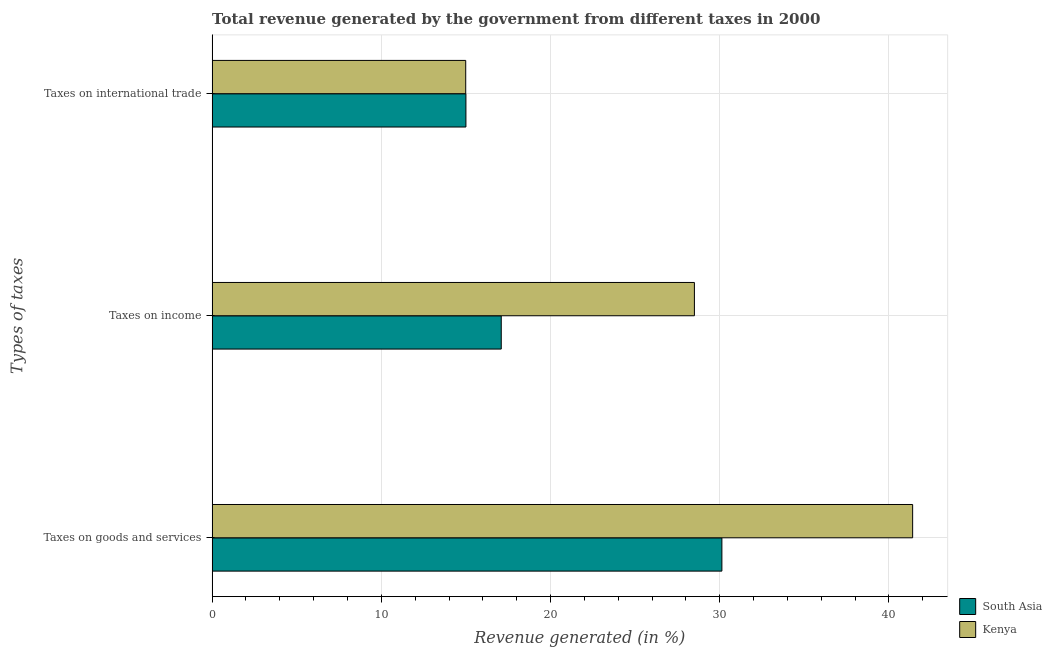How many different coloured bars are there?
Your response must be concise. 2. How many groups of bars are there?
Your answer should be very brief. 3. Are the number of bars on each tick of the Y-axis equal?
Give a very brief answer. Yes. How many bars are there on the 3rd tick from the top?
Offer a terse response. 2. How many bars are there on the 3rd tick from the bottom?
Offer a terse response. 2. What is the label of the 1st group of bars from the top?
Ensure brevity in your answer.  Taxes on international trade. What is the percentage of revenue generated by taxes on goods and services in South Asia?
Give a very brief answer. 30.13. Across all countries, what is the maximum percentage of revenue generated by taxes on goods and services?
Provide a succinct answer. 41.4. Across all countries, what is the minimum percentage of revenue generated by tax on international trade?
Offer a very short reply. 14.99. In which country was the percentage of revenue generated by taxes on income maximum?
Give a very brief answer. Kenya. In which country was the percentage of revenue generated by taxes on income minimum?
Ensure brevity in your answer.  South Asia. What is the total percentage of revenue generated by taxes on income in the graph?
Your answer should be very brief. 45.59. What is the difference between the percentage of revenue generated by taxes on goods and services in Kenya and that in South Asia?
Your answer should be compact. 11.27. What is the difference between the percentage of revenue generated by tax on international trade in South Asia and the percentage of revenue generated by taxes on goods and services in Kenya?
Your answer should be compact. -26.4. What is the average percentage of revenue generated by taxes on income per country?
Keep it short and to the point. 22.8. What is the difference between the percentage of revenue generated by tax on international trade and percentage of revenue generated by taxes on income in South Asia?
Keep it short and to the point. -2.09. In how many countries, is the percentage of revenue generated by tax on international trade greater than 4 %?
Provide a succinct answer. 2. What is the ratio of the percentage of revenue generated by taxes on income in Kenya to that in South Asia?
Provide a succinct answer. 1.67. Is the percentage of revenue generated by tax on international trade in South Asia less than that in Kenya?
Give a very brief answer. No. Is the difference between the percentage of revenue generated by taxes on income in South Asia and Kenya greater than the difference between the percentage of revenue generated by tax on international trade in South Asia and Kenya?
Make the answer very short. No. What is the difference between the highest and the second highest percentage of revenue generated by taxes on goods and services?
Provide a short and direct response. 11.27. What is the difference between the highest and the lowest percentage of revenue generated by tax on international trade?
Provide a short and direct response. 0.01. In how many countries, is the percentage of revenue generated by taxes on goods and services greater than the average percentage of revenue generated by taxes on goods and services taken over all countries?
Provide a short and direct response. 1. Is the sum of the percentage of revenue generated by taxes on goods and services in Kenya and South Asia greater than the maximum percentage of revenue generated by taxes on income across all countries?
Ensure brevity in your answer.  Yes. What does the 1st bar from the top in Taxes on goods and services represents?
Keep it short and to the point. Kenya. Is it the case that in every country, the sum of the percentage of revenue generated by taxes on goods and services and percentage of revenue generated by taxes on income is greater than the percentage of revenue generated by tax on international trade?
Your answer should be very brief. Yes. Are all the bars in the graph horizontal?
Provide a succinct answer. Yes. How many countries are there in the graph?
Keep it short and to the point. 2. What is the difference between two consecutive major ticks on the X-axis?
Offer a very short reply. 10. Are the values on the major ticks of X-axis written in scientific E-notation?
Offer a very short reply. No. Does the graph contain any zero values?
Your answer should be very brief. No. Does the graph contain grids?
Keep it short and to the point. Yes. Where does the legend appear in the graph?
Make the answer very short. Bottom right. How many legend labels are there?
Offer a very short reply. 2. How are the legend labels stacked?
Provide a short and direct response. Vertical. What is the title of the graph?
Keep it short and to the point. Total revenue generated by the government from different taxes in 2000. Does "Senegal" appear as one of the legend labels in the graph?
Make the answer very short. No. What is the label or title of the X-axis?
Your answer should be very brief. Revenue generated (in %). What is the label or title of the Y-axis?
Offer a terse response. Types of taxes. What is the Revenue generated (in %) in South Asia in Taxes on goods and services?
Provide a succinct answer. 30.13. What is the Revenue generated (in %) of Kenya in Taxes on goods and services?
Give a very brief answer. 41.4. What is the Revenue generated (in %) of South Asia in Taxes on income?
Provide a short and direct response. 17.09. What is the Revenue generated (in %) in Kenya in Taxes on income?
Make the answer very short. 28.5. What is the Revenue generated (in %) of South Asia in Taxes on international trade?
Keep it short and to the point. 15. What is the Revenue generated (in %) in Kenya in Taxes on international trade?
Keep it short and to the point. 14.99. Across all Types of taxes, what is the maximum Revenue generated (in %) in South Asia?
Offer a very short reply. 30.13. Across all Types of taxes, what is the maximum Revenue generated (in %) in Kenya?
Provide a succinct answer. 41.4. Across all Types of taxes, what is the minimum Revenue generated (in %) of South Asia?
Offer a very short reply. 15. Across all Types of taxes, what is the minimum Revenue generated (in %) of Kenya?
Keep it short and to the point. 14.99. What is the total Revenue generated (in %) of South Asia in the graph?
Provide a succinct answer. 62.21. What is the total Revenue generated (in %) of Kenya in the graph?
Offer a terse response. 84.89. What is the difference between the Revenue generated (in %) in South Asia in Taxes on goods and services and that in Taxes on income?
Offer a terse response. 13.04. What is the difference between the Revenue generated (in %) of Kenya in Taxes on goods and services and that in Taxes on income?
Provide a succinct answer. 12.9. What is the difference between the Revenue generated (in %) of South Asia in Taxes on goods and services and that in Taxes on international trade?
Keep it short and to the point. 15.13. What is the difference between the Revenue generated (in %) of Kenya in Taxes on goods and services and that in Taxes on international trade?
Ensure brevity in your answer.  26.41. What is the difference between the Revenue generated (in %) of South Asia in Taxes on income and that in Taxes on international trade?
Offer a terse response. 2.09. What is the difference between the Revenue generated (in %) of Kenya in Taxes on income and that in Taxes on international trade?
Offer a terse response. 13.52. What is the difference between the Revenue generated (in %) in South Asia in Taxes on goods and services and the Revenue generated (in %) in Kenya in Taxes on income?
Keep it short and to the point. 1.62. What is the difference between the Revenue generated (in %) in South Asia in Taxes on goods and services and the Revenue generated (in %) in Kenya in Taxes on international trade?
Give a very brief answer. 15.14. What is the difference between the Revenue generated (in %) in South Asia in Taxes on income and the Revenue generated (in %) in Kenya in Taxes on international trade?
Give a very brief answer. 2.1. What is the average Revenue generated (in %) of South Asia per Types of taxes?
Keep it short and to the point. 20.74. What is the average Revenue generated (in %) of Kenya per Types of taxes?
Your response must be concise. 28.3. What is the difference between the Revenue generated (in %) in South Asia and Revenue generated (in %) in Kenya in Taxes on goods and services?
Make the answer very short. -11.27. What is the difference between the Revenue generated (in %) of South Asia and Revenue generated (in %) of Kenya in Taxes on income?
Provide a short and direct response. -11.42. What is the difference between the Revenue generated (in %) of South Asia and Revenue generated (in %) of Kenya in Taxes on international trade?
Give a very brief answer. 0.01. What is the ratio of the Revenue generated (in %) of South Asia in Taxes on goods and services to that in Taxes on income?
Provide a succinct answer. 1.76. What is the ratio of the Revenue generated (in %) of Kenya in Taxes on goods and services to that in Taxes on income?
Your response must be concise. 1.45. What is the ratio of the Revenue generated (in %) in South Asia in Taxes on goods and services to that in Taxes on international trade?
Give a very brief answer. 2.01. What is the ratio of the Revenue generated (in %) of Kenya in Taxes on goods and services to that in Taxes on international trade?
Your answer should be compact. 2.76. What is the ratio of the Revenue generated (in %) in South Asia in Taxes on income to that in Taxes on international trade?
Your answer should be very brief. 1.14. What is the ratio of the Revenue generated (in %) in Kenya in Taxes on income to that in Taxes on international trade?
Provide a succinct answer. 1.9. What is the difference between the highest and the second highest Revenue generated (in %) of South Asia?
Make the answer very short. 13.04. What is the difference between the highest and the second highest Revenue generated (in %) in Kenya?
Give a very brief answer. 12.9. What is the difference between the highest and the lowest Revenue generated (in %) of South Asia?
Keep it short and to the point. 15.13. What is the difference between the highest and the lowest Revenue generated (in %) in Kenya?
Ensure brevity in your answer.  26.41. 